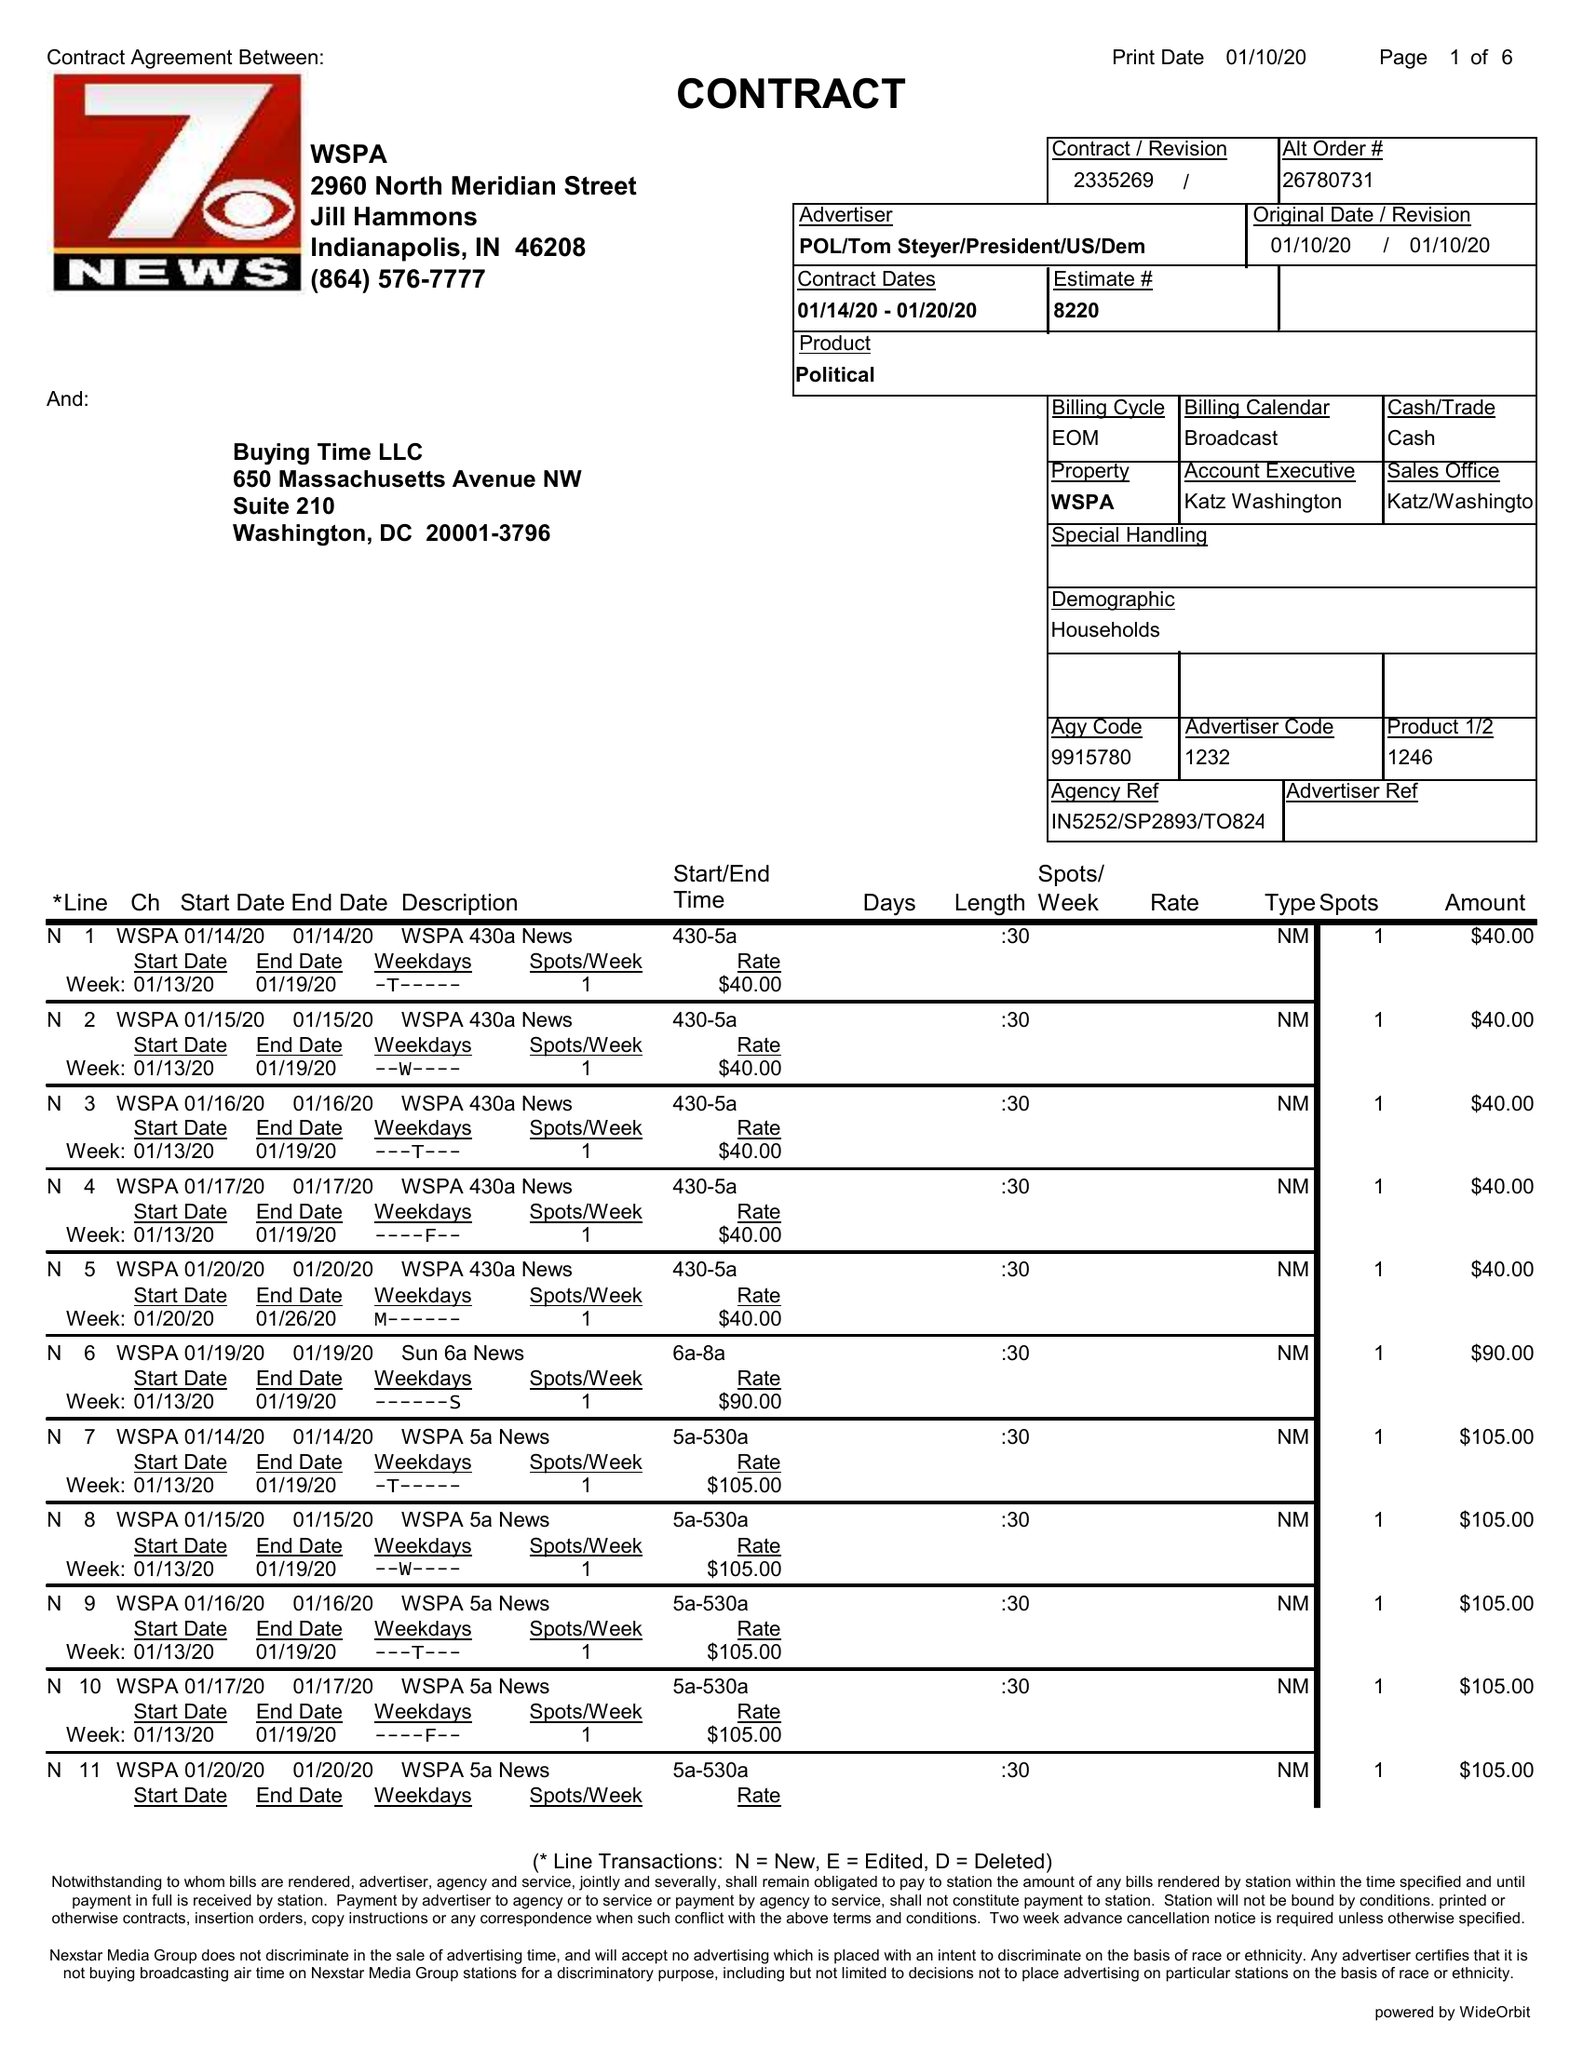What is the value for the flight_from?
Answer the question using a single word or phrase. 01/14/20 